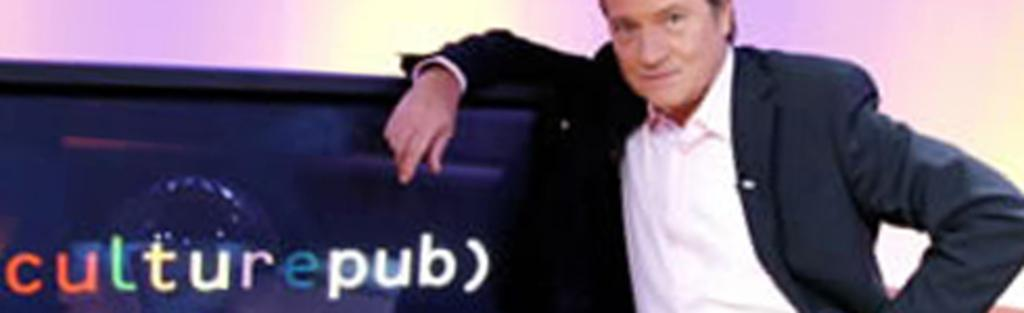What is the main subject of the image? There is a person in the image. Can you describe any other objects or elements in the image? There is an object with text in the image. What type of wrench is being used by the person in the image? There is no wrench present in the image. How does the person start the rainstorm in the image? There is no rainstorm present in the image, and the person is not starting one. 